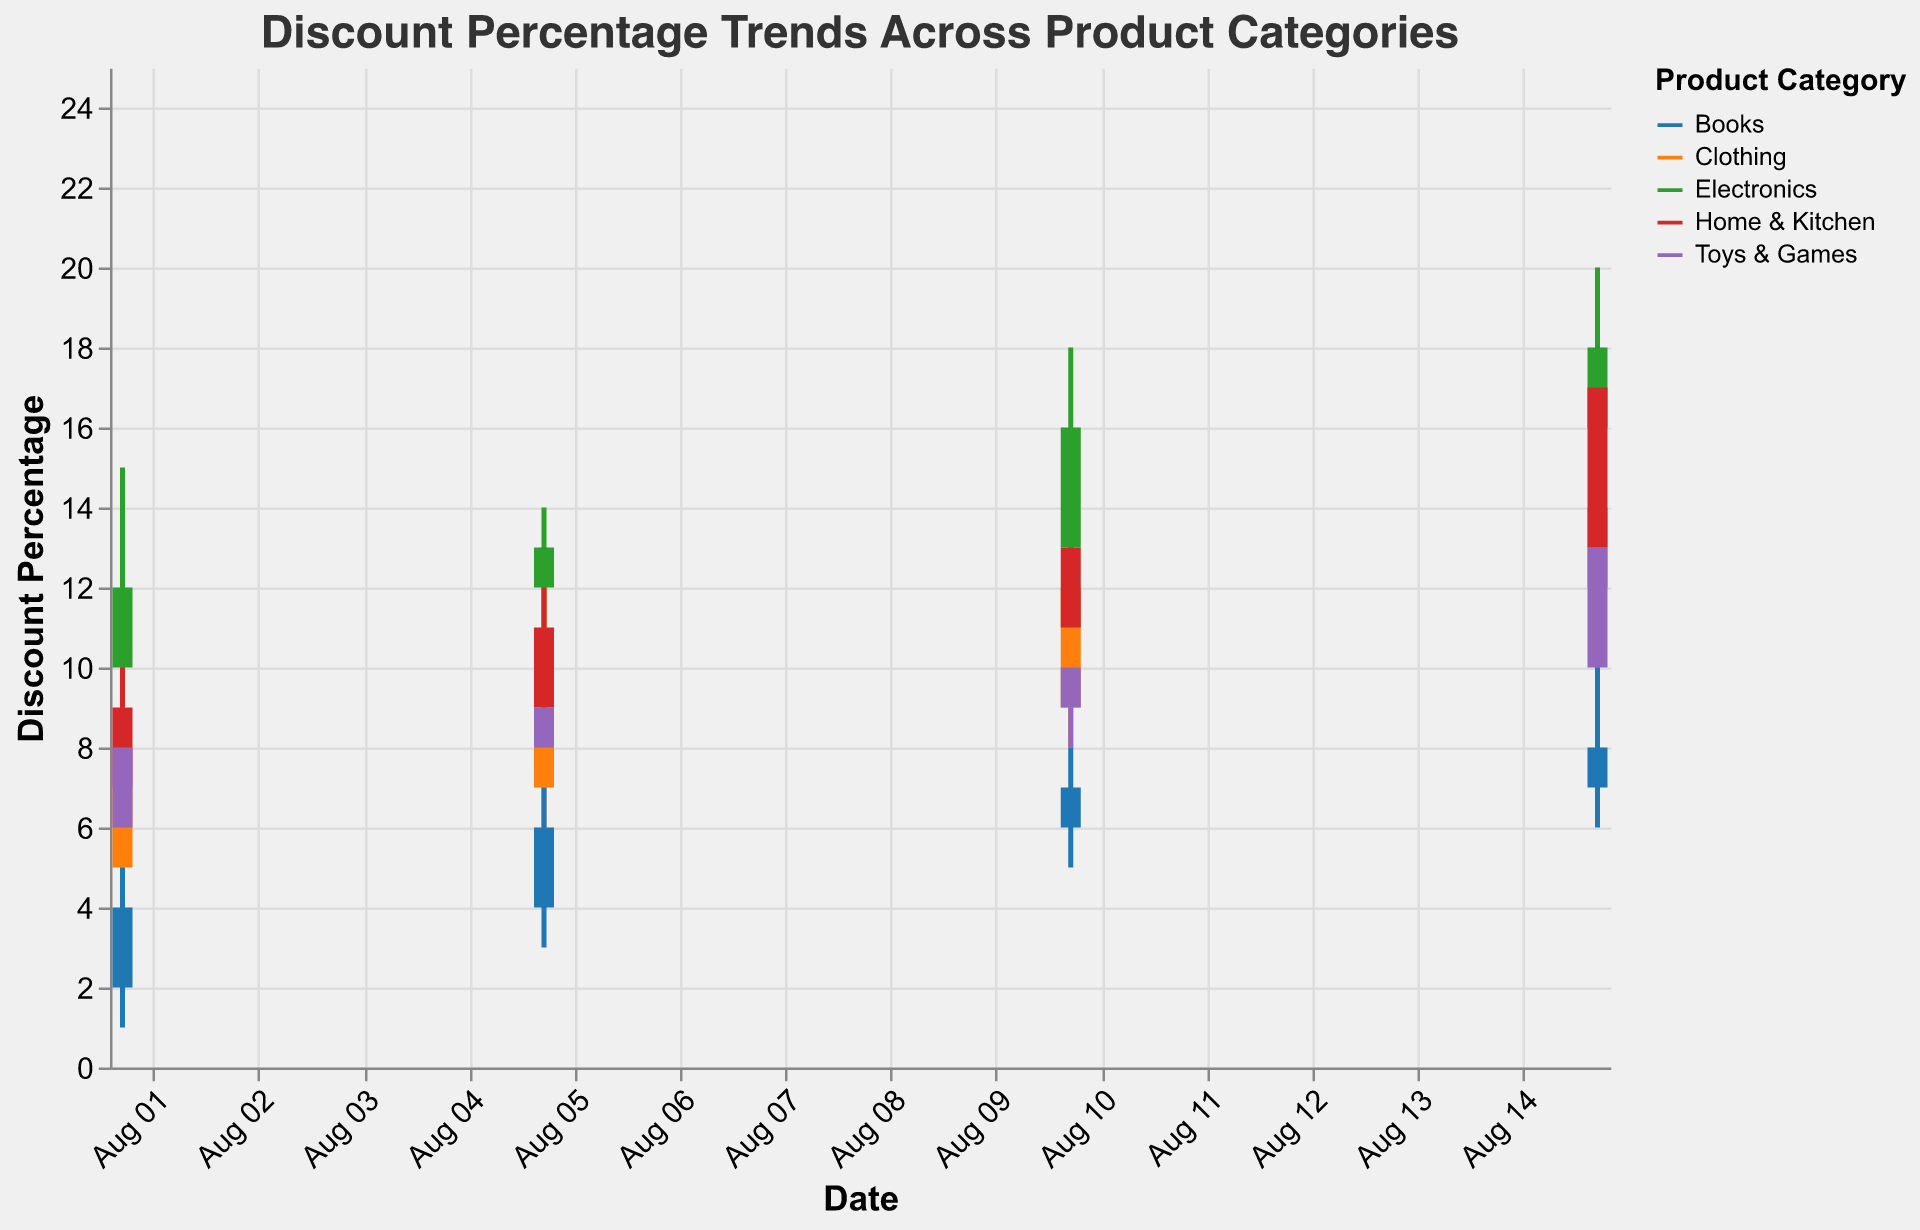What’s the discount percentage trend for Electronics on August 15? The candlestick for Electronics on August 15 shows an opening discount of 16%, a high of 20%, a low of 15%, and closes at 18%.
Answer: The trend indicates the discount increased from 16% to 18% with fluctuations between 15% and 20% Which category had the highest discount percentage on August 15? On August 15, "Home & Kitchen" reached the highest discount percentage with its high point at 18%.
Answer: Home & Kitchen How does the discount trend for Clothing compare from August 1 to August 15? The discount for Clothing started at 7% on August 1 and increased over time: August 5 at 9%, August 10 at 12%, and finally August 15 at 14%.
Answer: The discount increased steadily What is the average high discount percentage for Toys & Games across the given dates? The high discount percentages for Toys & Games on the given dates are 9%, 11%, 13%, and 14%. The average is (9 + 11 + 13 + 14) / 4 = 11.75%.
Answer: 11.75% Did Electronics or Books have a higher closing discount percentage on August 10? On August 10, Electronics had a closing discount of 16%, while Books had a closing discount of 7%.
Answer: Electronics Which date had the least variation in discount percentage for Home & Kitchen? The least variation in discount percentage for Home & Kitchen can be determined by comparing the differences between the high and low values. For each date: August 1 (11-5=6%), August 5 (13-8=5%), August 10 (14-9=5%), August 15 (18-11=7%). The smallest variation is on August 5 and August 10.
Answer: August 5 and August 10 What is the range of discount percentages for Books on August 5? For Books on August 5, the discount percentage ranged from a low of 3% to a high of 7%.
Answer: 3% to 7% Between August 1 and August 15, which category shows the most significant increase in the closing discount percentage? Calculating the increase for each category: Electronics (18-12=6%), Clothing (14-7=7%), Home & Kitchen (17-9=8%), Toys & Games (13-8=5%), Books (8-4=4%). Home & Kitchen shows the most significant increase.
Answer: Home & Kitchen If I am looking for the highest closing discount across all dates and categories, which one should I consider? The highest closing discount across all dates and categories is "Home & Kitchen" with a closing discount of 17% on August 15.
Answer: Home & Kitchen on August 15 